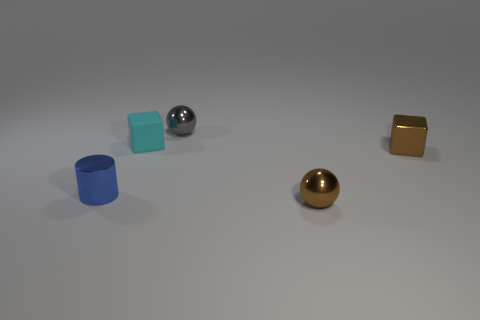Do the blue object and the brown shiny block have the same size?
Ensure brevity in your answer.  Yes. What size is the sphere that is behind the sphere that is in front of the metal cylinder?
Give a very brief answer. Small. There is a tiny metal cube; is its color the same as the tiny thing that is in front of the tiny blue cylinder?
Ensure brevity in your answer.  Yes. Is there a blue matte cube that has the same size as the blue metallic object?
Offer a terse response. No. There is a object in front of the tiny blue object; are there any tiny brown metallic cubes that are behind it?
Your answer should be very brief. Yes. How many other things are the same shape as the small cyan rubber thing?
Keep it short and to the point. 1. There is a small object that is both in front of the brown metal block and to the right of the blue metal object; what color is it?
Offer a terse response. Brown. What size is the metallic ball that is the same color as the metal cube?
Make the answer very short. Small. What number of tiny things are blocks or green metallic balls?
Your answer should be very brief. 2. Is there anything else of the same color as the cylinder?
Your answer should be compact. No. 